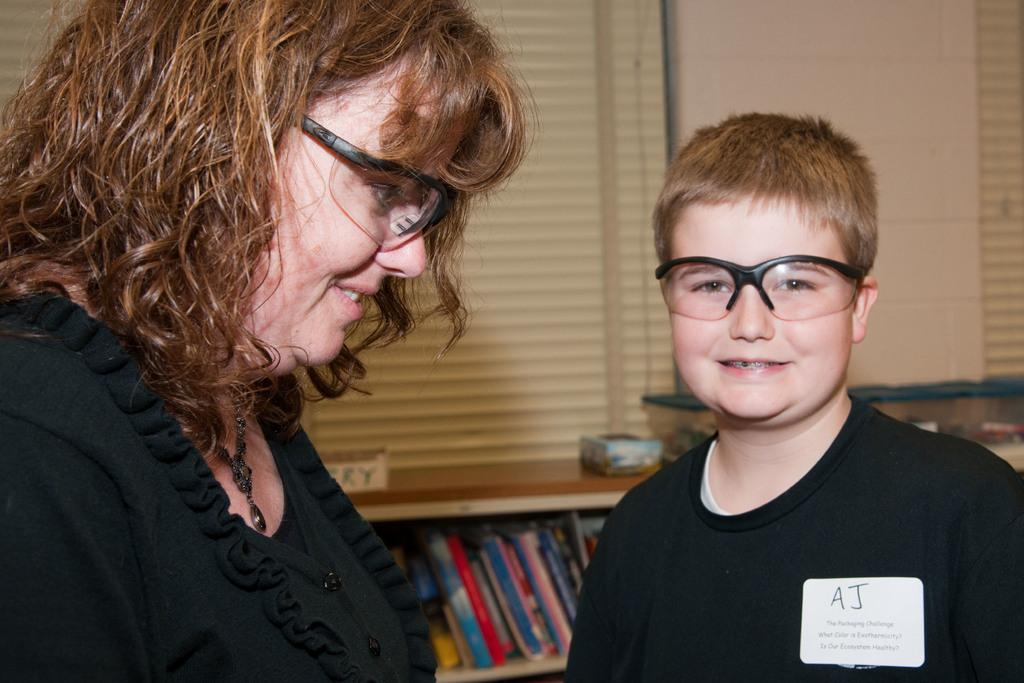How many people are in the room? There are 2 people in the room. What are the people wearing? The people are wearing black dresses and glasses. What can be found on the shelves in the room? There are books on the shelves in the room. What type of window treatment is present in the room? There are window blinds at the back of the room. What type of pig is sitting on the grandmother's lap in the image? There is no grandmother or pig present in the image. How does the person with the glasses clear their throat in the image? There is no indication of anyone clearing their throat in the image. 